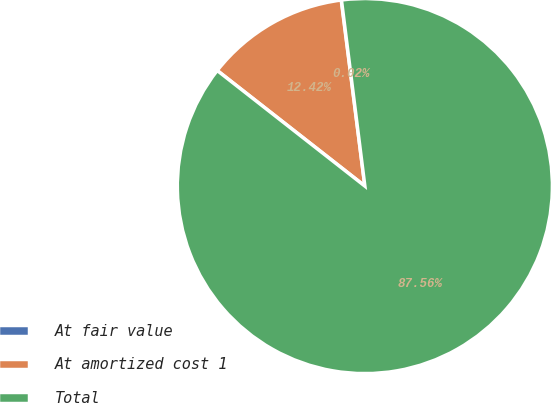Convert chart to OTSL. <chart><loc_0><loc_0><loc_500><loc_500><pie_chart><fcel>At fair value<fcel>At amortized cost 1<fcel>Total<nl><fcel>0.02%<fcel>12.42%<fcel>87.57%<nl></chart> 